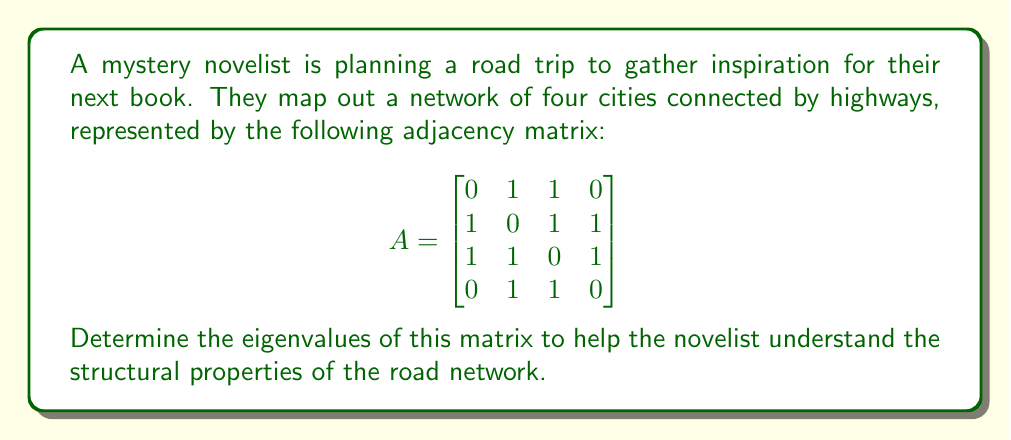Provide a solution to this math problem. To find the eigenvalues of matrix $A$, we need to solve the characteristic equation:

1) First, we form the characteristic polynomial:
   $det(A - \lambda I) = 0$

2) Expand the determinant:
   $$\begin{vmatrix}
   -\lambda & 1 & 1 & 0 \\
   1 & -\lambda & 1 & 1 \\
   1 & 1 & -\lambda & 1 \\
   0 & 1 & 1 & -\lambda
   \end{vmatrix} = 0$$

3) Calculate the determinant:
   $\lambda^4 - 3\lambda^2 - 2\lambda - 1 = 0$

4) This is a 4th-degree polynomial. We can factor it:
   $(\lambda + 1)(\lambda - 1)(\lambda^2 - 2\lambda - 1) = 0$

5) Solve each factor:
   $\lambda = -1$ or $\lambda = 1$ or $\lambda^2 - 2\lambda - 1 = 0$

6) For the quadratic factor, use the quadratic formula:
   $\lambda = \frac{2 \pm \sqrt{4 + 4}}{2} = 1 \pm \sqrt{2}$

Therefore, the eigenvalues are:
$\lambda_1 = -1$, $\lambda_2 = 1$, $\lambda_3 = 1 + \sqrt{2}$, $\lambda_4 = 1 - \sqrt{2}$
Answer: $-1, 1, 1+\sqrt{2}, 1-\sqrt{2}$ 